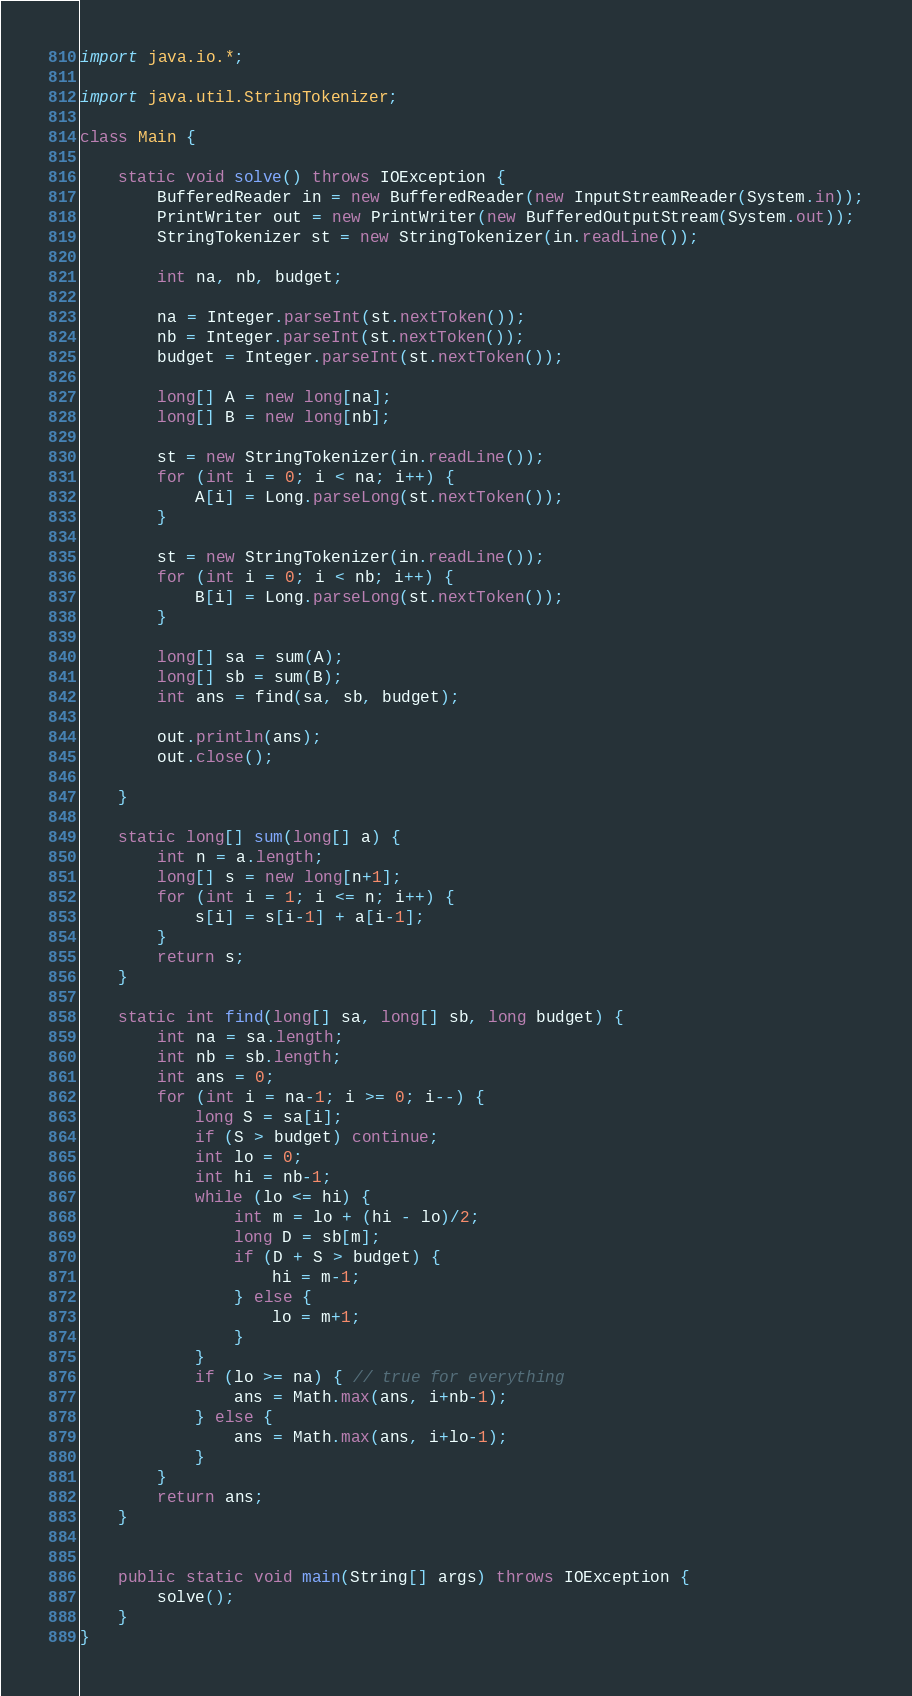Convert code to text. <code><loc_0><loc_0><loc_500><loc_500><_Java_>import java.io.*;

import java.util.StringTokenizer;

class Main {

    static void solve() throws IOException {
        BufferedReader in = new BufferedReader(new InputStreamReader(System.in));
        PrintWriter out = new PrintWriter(new BufferedOutputStream(System.out));
        StringTokenizer st = new StringTokenizer(in.readLine());

        int na, nb, budget;

        na = Integer.parseInt(st.nextToken());
        nb = Integer.parseInt(st.nextToken());
        budget = Integer.parseInt(st.nextToken());

        long[] A = new long[na];
        long[] B = new long[nb];

        st = new StringTokenizer(in.readLine());
        for (int i = 0; i < na; i++) {
            A[i] = Long.parseLong(st.nextToken());
        }

        st = new StringTokenizer(in.readLine());
        for (int i = 0; i < nb; i++) {
            B[i] = Long.parseLong(st.nextToken());
        }

        long[] sa = sum(A);
        long[] sb = sum(B);
        int ans = find(sa, sb, budget);

        out.println(ans);
        out.close();

    }

    static long[] sum(long[] a) {
        int n = a.length;
        long[] s = new long[n+1];
        for (int i = 1; i <= n; i++) {
            s[i] = s[i-1] + a[i-1];
        }
        return s;
    }

    static int find(long[] sa, long[] sb, long budget) {
        int na = sa.length;
        int nb = sb.length;
        int ans = 0;
        for (int i = na-1; i >= 0; i--) {
            long S = sa[i];
            if (S > budget) continue;
            int lo = 0;
            int hi = nb-1;
            while (lo <= hi) {
                int m = lo + (hi - lo)/2;
                long D = sb[m];
                if (D + S > budget) {
                    hi = m-1;
                } else {
                    lo = m+1;
                }
            }
            if (lo >= na) { // true for everything
                ans = Math.max(ans, i+nb-1);
            } else {
                ans = Math.max(ans, i+lo-1);
            }
        }
        return ans;
    }


    public static void main(String[] args) throws IOException {
        solve();
    }
}</code> 